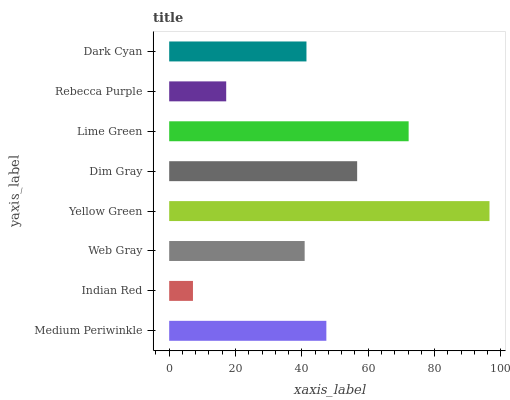Is Indian Red the minimum?
Answer yes or no. Yes. Is Yellow Green the maximum?
Answer yes or no. Yes. Is Web Gray the minimum?
Answer yes or no. No. Is Web Gray the maximum?
Answer yes or no. No. Is Web Gray greater than Indian Red?
Answer yes or no. Yes. Is Indian Red less than Web Gray?
Answer yes or no. Yes. Is Indian Red greater than Web Gray?
Answer yes or no. No. Is Web Gray less than Indian Red?
Answer yes or no. No. Is Medium Periwinkle the high median?
Answer yes or no. Yes. Is Dark Cyan the low median?
Answer yes or no. Yes. Is Web Gray the high median?
Answer yes or no. No. Is Web Gray the low median?
Answer yes or no. No. 